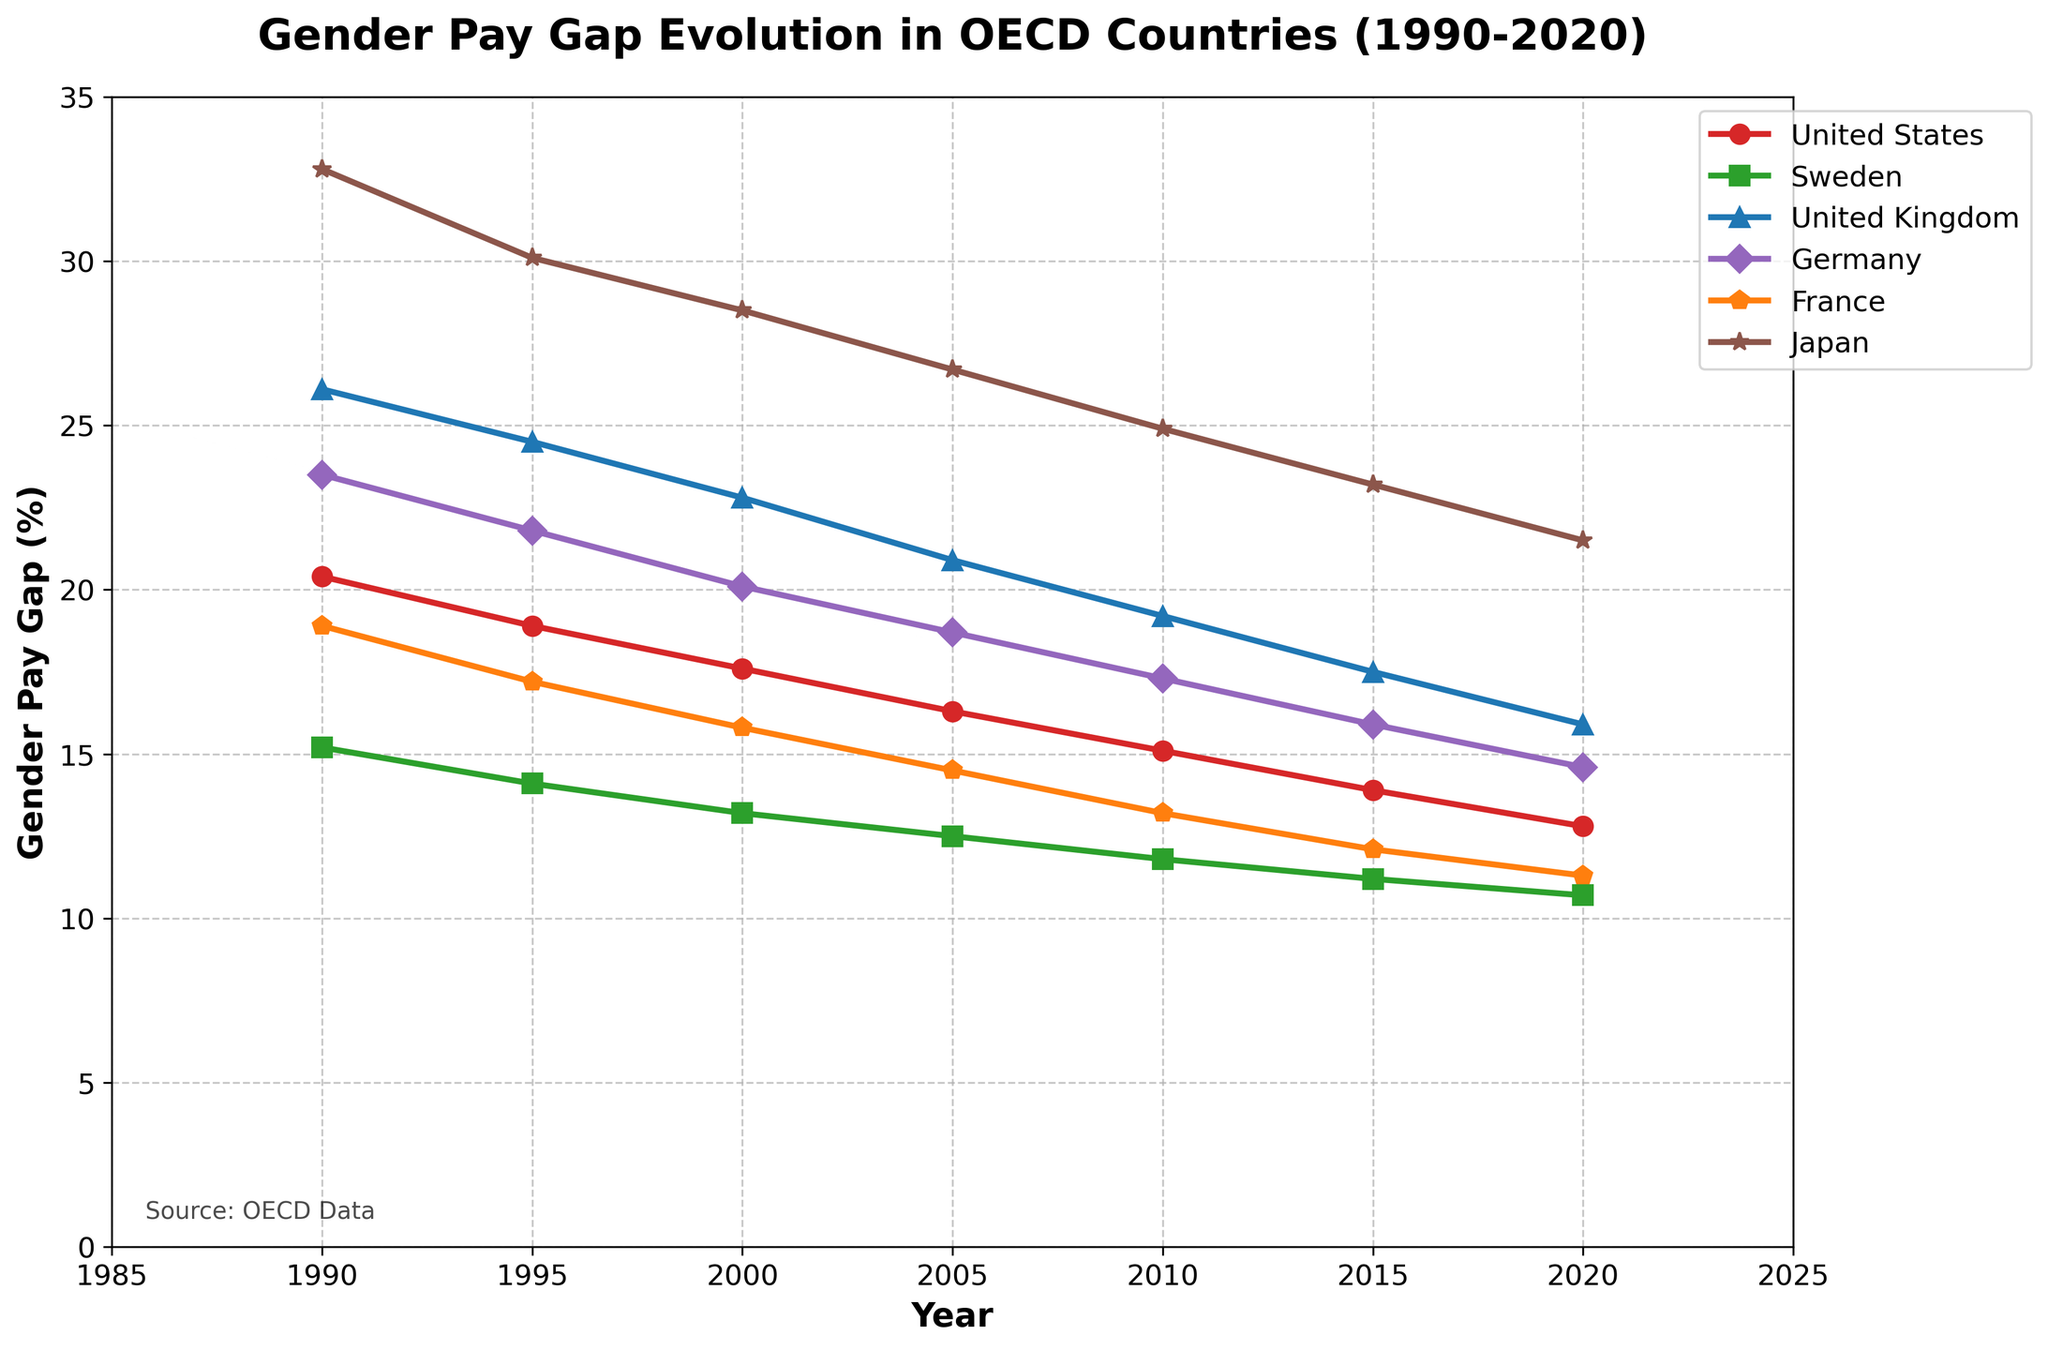What was the gender pay gap in the United States in 1990 and how has it changed by 2020? The gender pay gap in the United States in 1990 was 20.4%. By 2020, it had decreased to 12.8%. To find the change, subtract the later value from the earlier one: 20.4% - 12.8% = 7.6%.
Answer: The gender pay gap decreased by 7.6 percentage points Which country had the highest gender pay gap in 1990 and which one had the lowest in 2020? In 1990, Japan had the highest gender pay gap at 32.8%. In 2020, Sweden had the lowest gender pay gap at 10.7%.
Answer: Highest: Japan in 1990, Lowest: Sweden in 2020 How does the gender pay gap in France in 2000 compare to that in Sweden in the same year? The gender pay gap in France in 2000 was 15.8%. In Sweden, it was 13.2%. Compare the two values: 15.8% is greater than 13.2%.
Answer: France's gap was greater by 2.6 percentage points By how many percentage points did the gender pay gap in Germany decrease from 1990 to 2010? The gender pay gap in Germany was 23.5% in 1990 and 17.3% in 2010. Subtract the latter from the former: 23.5% - 17.3% = 6.2%.
Answer: 6.2 percentage points What general trend can be observed in the gender pay gap among the countries from 1990 to 2020? Observing the lines, we note that the gender pay gap has generally decreased in all countries over the period from 1990 to 2020, though the rate of decrease varies by country.
Answer: General decrease 